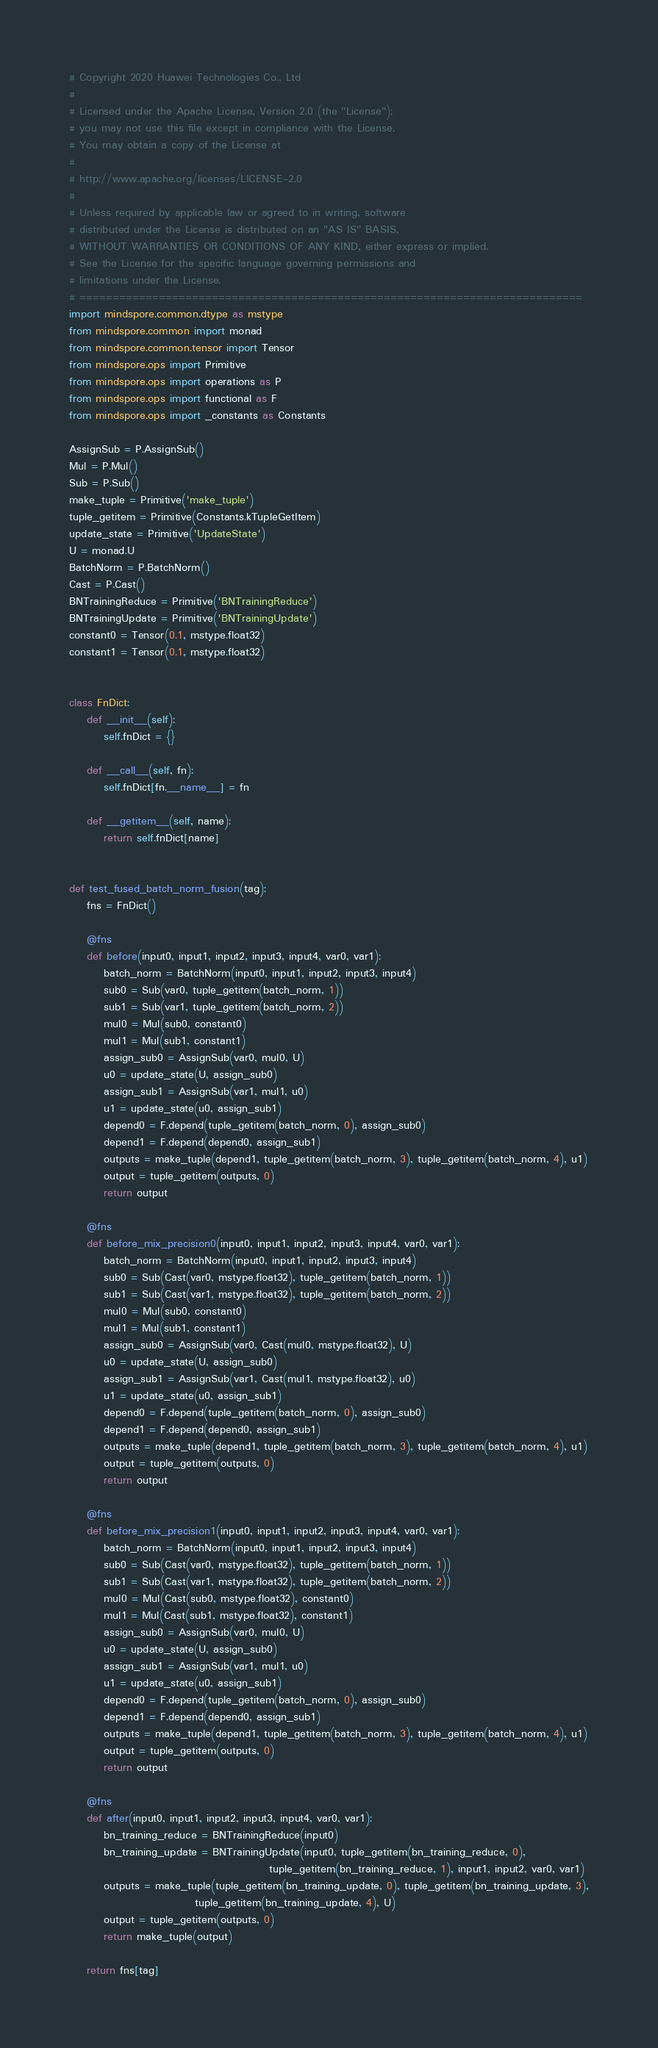<code> <loc_0><loc_0><loc_500><loc_500><_Python_># Copyright 2020 Huawei Technologies Co., Ltd
#
# Licensed under the Apache License, Version 2.0 (the "License");
# you may not use this file except in compliance with the License.
# You may obtain a copy of the License at
#
# http://www.apache.org/licenses/LICENSE-2.0
#
# Unless required by applicable law or agreed to in writing, software
# distributed under the License is distributed on an "AS IS" BASIS,
# WITHOUT WARRANTIES OR CONDITIONS OF ANY KIND, either express or implied.
# See the License for the specific language governing permissions and
# limitations under the License.
# ============================================================================
import mindspore.common.dtype as mstype
from mindspore.common import monad
from mindspore.common.tensor import Tensor
from mindspore.ops import Primitive
from mindspore.ops import operations as P
from mindspore.ops import functional as F
from mindspore.ops import _constants as Constants

AssignSub = P.AssignSub()
Mul = P.Mul()
Sub = P.Sub()
make_tuple = Primitive('make_tuple')
tuple_getitem = Primitive(Constants.kTupleGetItem)
update_state = Primitive('UpdateState')
U = monad.U
BatchNorm = P.BatchNorm()
Cast = P.Cast()
BNTrainingReduce = Primitive('BNTrainingReduce')
BNTrainingUpdate = Primitive('BNTrainingUpdate')
constant0 = Tensor(0.1, mstype.float32)
constant1 = Tensor(0.1, mstype.float32)


class FnDict:
    def __init__(self):
        self.fnDict = {}

    def __call__(self, fn):
        self.fnDict[fn.__name__] = fn

    def __getitem__(self, name):
        return self.fnDict[name]


def test_fused_batch_norm_fusion(tag):
    fns = FnDict()

    @fns
    def before(input0, input1, input2, input3, input4, var0, var1):
        batch_norm = BatchNorm(input0, input1, input2, input3, input4)
        sub0 = Sub(var0, tuple_getitem(batch_norm, 1))
        sub1 = Sub(var1, tuple_getitem(batch_norm, 2))
        mul0 = Mul(sub0, constant0)
        mul1 = Mul(sub1, constant1)
        assign_sub0 = AssignSub(var0, mul0, U)
        u0 = update_state(U, assign_sub0)
        assign_sub1 = AssignSub(var1, mul1, u0)
        u1 = update_state(u0, assign_sub1)
        depend0 = F.depend(tuple_getitem(batch_norm, 0), assign_sub0)
        depend1 = F.depend(depend0, assign_sub1)
        outputs = make_tuple(depend1, tuple_getitem(batch_norm, 3), tuple_getitem(batch_norm, 4), u1)
        output = tuple_getitem(outputs, 0)
        return output

    @fns
    def before_mix_precision0(input0, input1, input2, input3, input4, var0, var1):
        batch_norm = BatchNorm(input0, input1, input2, input3, input4)
        sub0 = Sub(Cast(var0, mstype.float32), tuple_getitem(batch_norm, 1))
        sub1 = Sub(Cast(var1, mstype.float32), tuple_getitem(batch_norm, 2))
        mul0 = Mul(sub0, constant0)
        mul1 = Mul(sub1, constant1)
        assign_sub0 = AssignSub(var0, Cast(mul0, mstype.float32), U)
        u0 = update_state(U, assign_sub0)
        assign_sub1 = AssignSub(var1, Cast(mul1, mstype.float32), u0)
        u1 = update_state(u0, assign_sub1)
        depend0 = F.depend(tuple_getitem(batch_norm, 0), assign_sub0)
        depend1 = F.depend(depend0, assign_sub1)
        outputs = make_tuple(depend1, tuple_getitem(batch_norm, 3), tuple_getitem(batch_norm, 4), u1)
        output = tuple_getitem(outputs, 0)
        return output

    @fns
    def before_mix_precision1(input0, input1, input2, input3, input4, var0, var1):
        batch_norm = BatchNorm(input0, input1, input2, input3, input4)
        sub0 = Sub(Cast(var0, mstype.float32), tuple_getitem(batch_norm, 1))
        sub1 = Sub(Cast(var1, mstype.float32), tuple_getitem(batch_norm, 2))
        mul0 = Mul(Cast(sub0, mstype.float32), constant0)
        mul1 = Mul(Cast(sub1, mstype.float32), constant1)
        assign_sub0 = AssignSub(var0, mul0, U)
        u0 = update_state(U, assign_sub0)
        assign_sub1 = AssignSub(var1, mul1, u0)
        u1 = update_state(u0, assign_sub1)
        depend0 = F.depend(tuple_getitem(batch_norm, 0), assign_sub0)
        depend1 = F.depend(depend0, assign_sub1)
        outputs = make_tuple(depend1, tuple_getitem(batch_norm, 3), tuple_getitem(batch_norm, 4), u1)
        output = tuple_getitem(outputs, 0)
        return output

    @fns
    def after(input0, input1, input2, input3, input4, var0, var1):
        bn_training_reduce = BNTrainingReduce(input0)
        bn_training_update = BNTrainingUpdate(input0, tuple_getitem(bn_training_reduce, 0),
                                              tuple_getitem(bn_training_reduce, 1), input1, input2, var0, var1)
        outputs = make_tuple(tuple_getitem(bn_training_update, 0), tuple_getitem(bn_training_update, 3),
                             tuple_getitem(bn_training_update, 4), U)
        output = tuple_getitem(outputs, 0)
        return make_tuple(output)

    return fns[tag]
</code> 